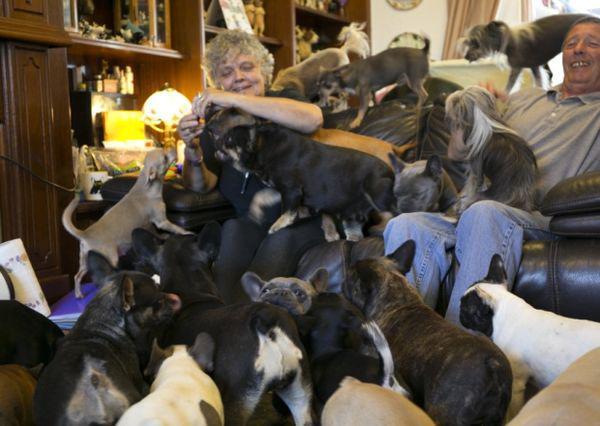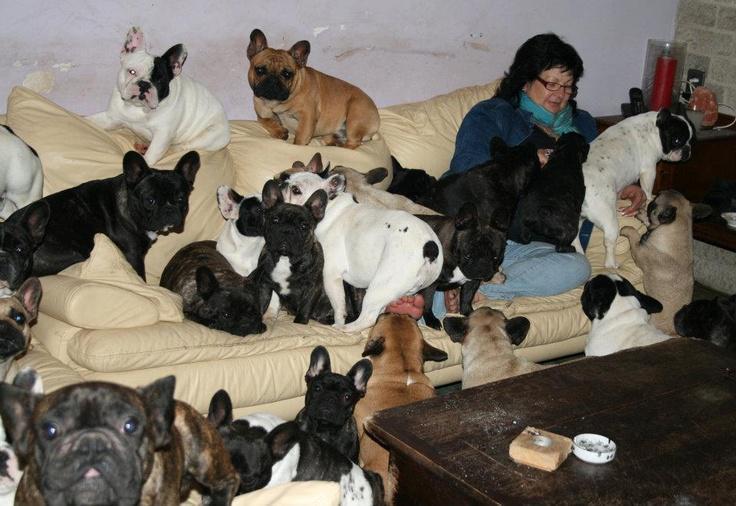The first image is the image on the left, the second image is the image on the right. Considering the images on both sides, is "An image shows exactly one dog, which is sitting." valid? Answer yes or no. No. 